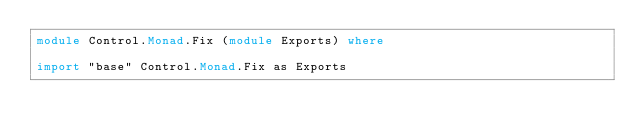<code> <loc_0><loc_0><loc_500><loc_500><_Haskell_>module Control.Monad.Fix (module Exports) where

import "base" Control.Monad.Fix as Exports
</code> 